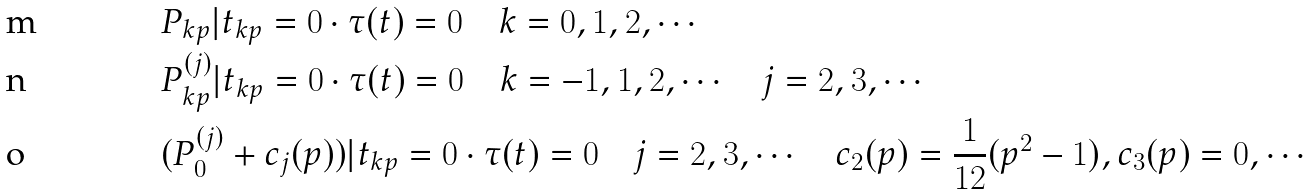<formula> <loc_0><loc_0><loc_500><loc_500>& P _ { k p } | t _ { k p } = 0 \cdot \tau ( t ) = 0 \quad k = 0 , 1 , 2 , \cdots \\ & P ^ { ( j ) } _ { k p } | t _ { k p } = 0 \cdot \tau ( t ) = 0 \quad k = - 1 , 1 , 2 , \cdots \quad j = 2 , 3 , \cdots \\ & ( P ^ { ( j ) } _ { 0 } + c _ { j } ( p ) ) | t _ { k p } = 0 \cdot \tau ( t ) = 0 \quad j = 2 , 3 , \cdots \quad c _ { 2 } ( p ) = \frac { 1 } { 1 2 } ( p ^ { 2 } - 1 ) , c _ { 3 } ( p ) = 0 , \cdots</formula> 